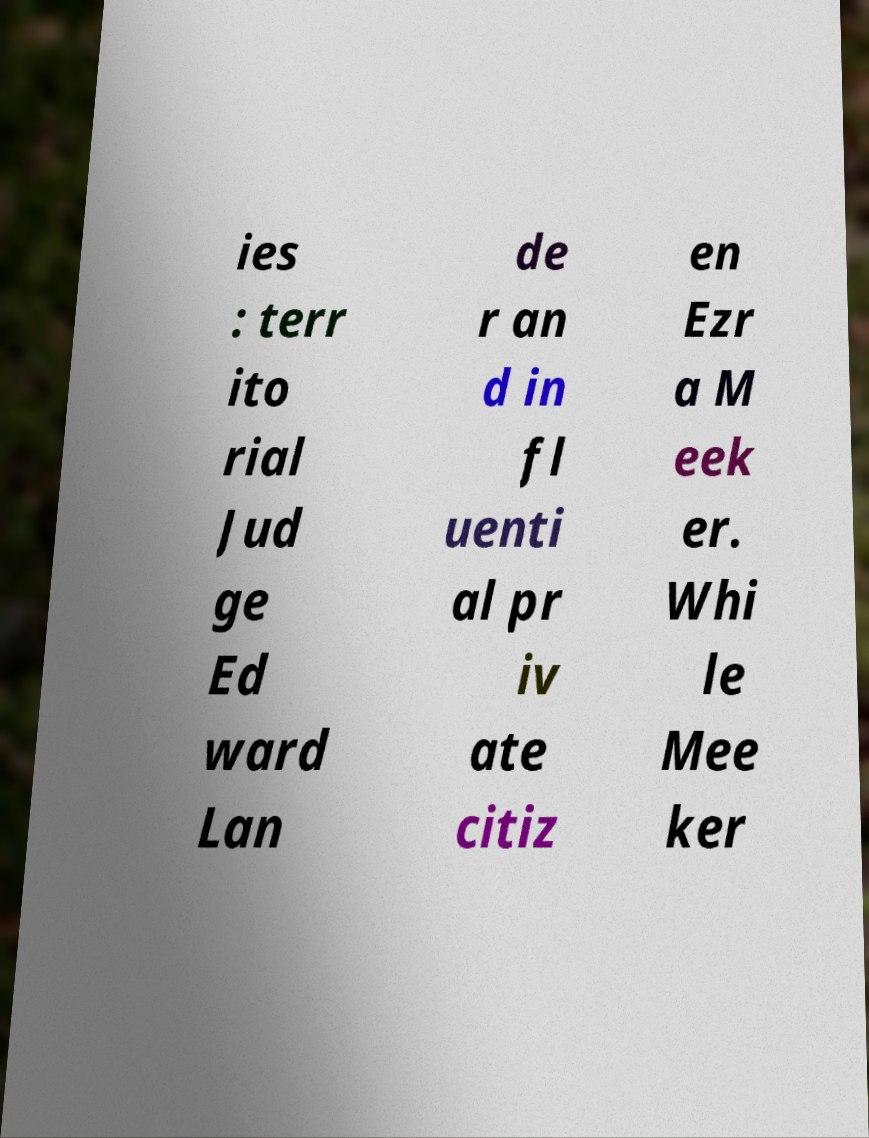There's text embedded in this image that I need extracted. Can you transcribe it verbatim? ies : terr ito rial Jud ge Ed ward Lan de r an d in fl uenti al pr iv ate citiz en Ezr a M eek er. Whi le Mee ker 